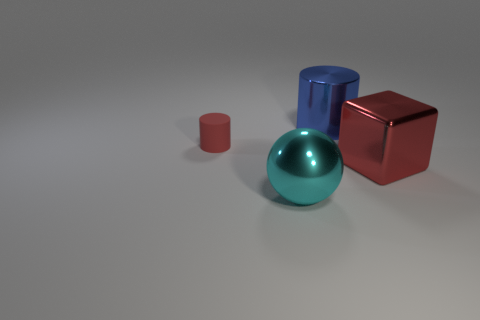Add 3 tiny cyan metal things. How many objects exist? 7 Subtract all blocks. How many objects are left? 3 Subtract 0 cyan cylinders. How many objects are left? 4 Subtract all large blue objects. Subtract all large red objects. How many objects are left? 2 Add 2 matte objects. How many matte objects are left? 3 Add 1 big red objects. How many big red objects exist? 2 